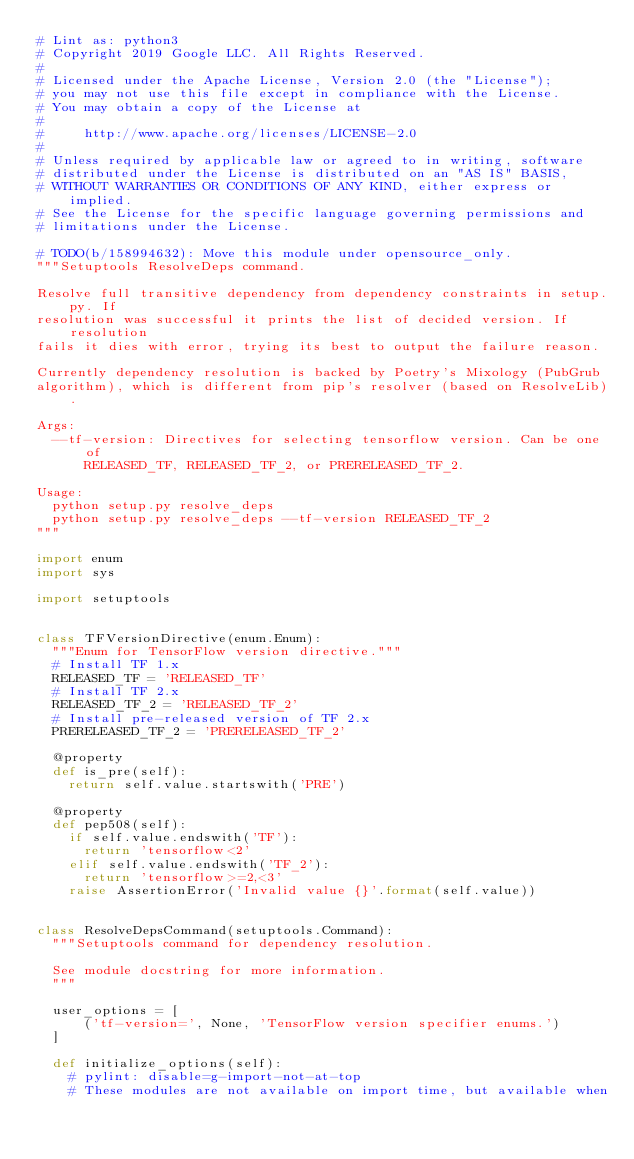<code> <loc_0><loc_0><loc_500><loc_500><_Python_># Lint as: python3
# Copyright 2019 Google LLC. All Rights Reserved.
#
# Licensed under the Apache License, Version 2.0 (the "License");
# you may not use this file except in compliance with the License.
# You may obtain a copy of the License at
#
#     http://www.apache.org/licenses/LICENSE-2.0
#
# Unless required by applicable law or agreed to in writing, software
# distributed under the License is distributed on an "AS IS" BASIS,
# WITHOUT WARRANTIES OR CONDITIONS OF ANY KIND, either express or implied.
# See the License for the specific language governing permissions and
# limitations under the License.

# TODO(b/158994632): Move this module under opensource_only.
"""Setuptools ResolveDeps command.

Resolve full transitive dependency from dependency constraints in setup.py. If
resolution was successful it prints the list of decided version. If resolution
fails it dies with error, trying its best to output the failure reason.

Currently dependency resolution is backed by Poetry's Mixology (PubGrub
algorithm), which is different from pip's resolver (based on ResolveLib).

Args:
  --tf-version: Directives for selecting tensorflow version. Can be one of
      RELEASED_TF, RELEASED_TF_2, or PRERELEASED_TF_2.

Usage:
  python setup.py resolve_deps
  python setup.py resolve_deps --tf-version RELEASED_TF_2
"""

import enum
import sys

import setuptools


class TFVersionDirective(enum.Enum):
  """Enum for TensorFlow version directive."""
  # Install TF 1.x
  RELEASED_TF = 'RELEASED_TF'
  # Install TF 2.x
  RELEASED_TF_2 = 'RELEASED_TF_2'
  # Install pre-released version of TF 2.x
  PRERELEASED_TF_2 = 'PRERELEASED_TF_2'

  @property
  def is_pre(self):
    return self.value.startswith('PRE')

  @property
  def pep508(self):
    if self.value.endswith('TF'):
      return 'tensorflow<2'
    elif self.value.endswith('TF_2'):
      return 'tensorflow>=2,<3'
    raise AssertionError('Invalid value {}'.format(self.value))


class ResolveDepsCommand(setuptools.Command):
  """Setuptools command for dependency resolution.

  See module docstring for more information.
  """

  user_options = [
      ('tf-version=', None, 'TensorFlow version specifier enums.')
  ]

  def initialize_options(self):
    # pylint: disable=g-import-not-at-top
    # These modules are not available on import time, but available when</code> 